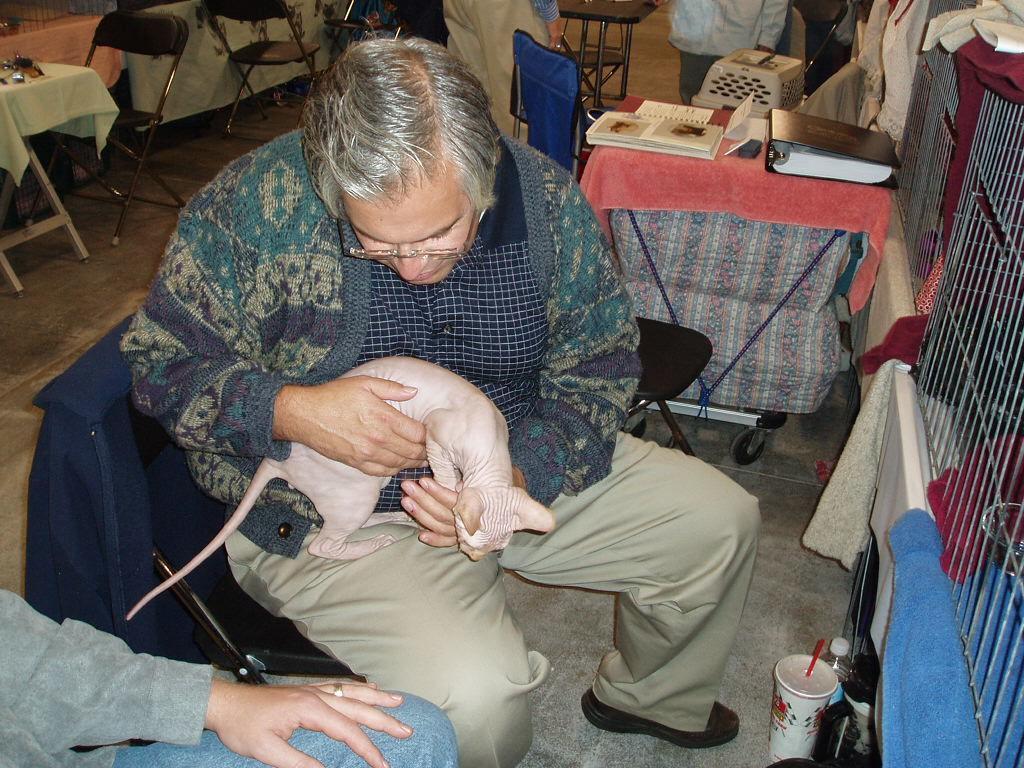Could you give a brief overview of what you see in this image? This picture describes about group of people few are seated on the chair and few are standing in the given image a middle person holding a cat in his hands, in front of him we can see cups and bottle, and also we can see books on the table. 